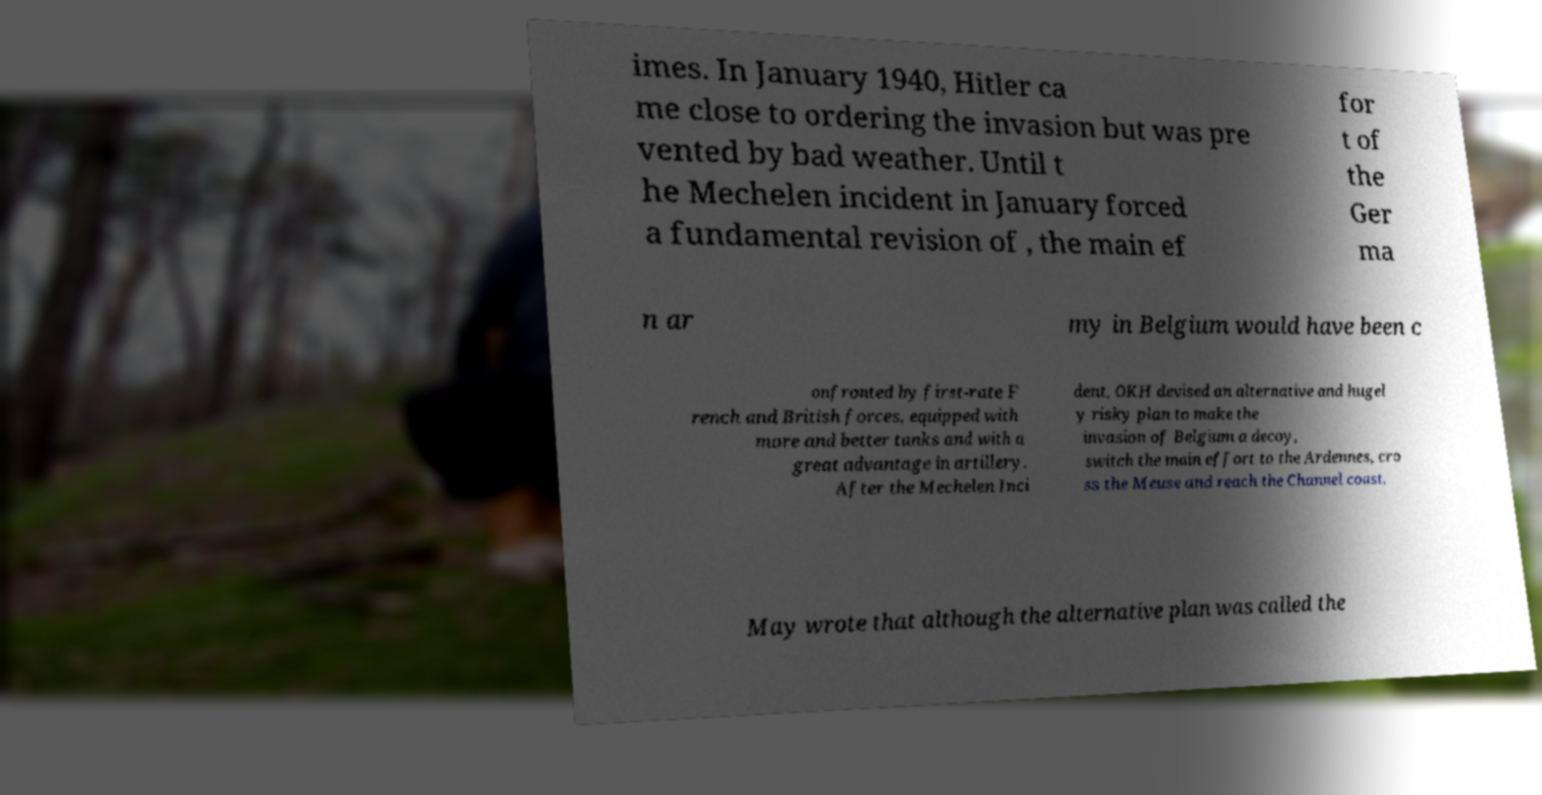Could you extract and type out the text from this image? imes. In January 1940, Hitler ca me close to ordering the invasion but was pre vented by bad weather. Until t he Mechelen incident in January forced a fundamental revision of , the main ef for t of the Ger ma n ar my in Belgium would have been c onfronted by first-rate F rench and British forces, equipped with more and better tanks and with a great advantage in artillery. After the Mechelen Inci dent, OKH devised an alternative and hugel y risky plan to make the invasion of Belgium a decoy, switch the main effort to the Ardennes, cro ss the Meuse and reach the Channel coast. May wrote that although the alternative plan was called the 